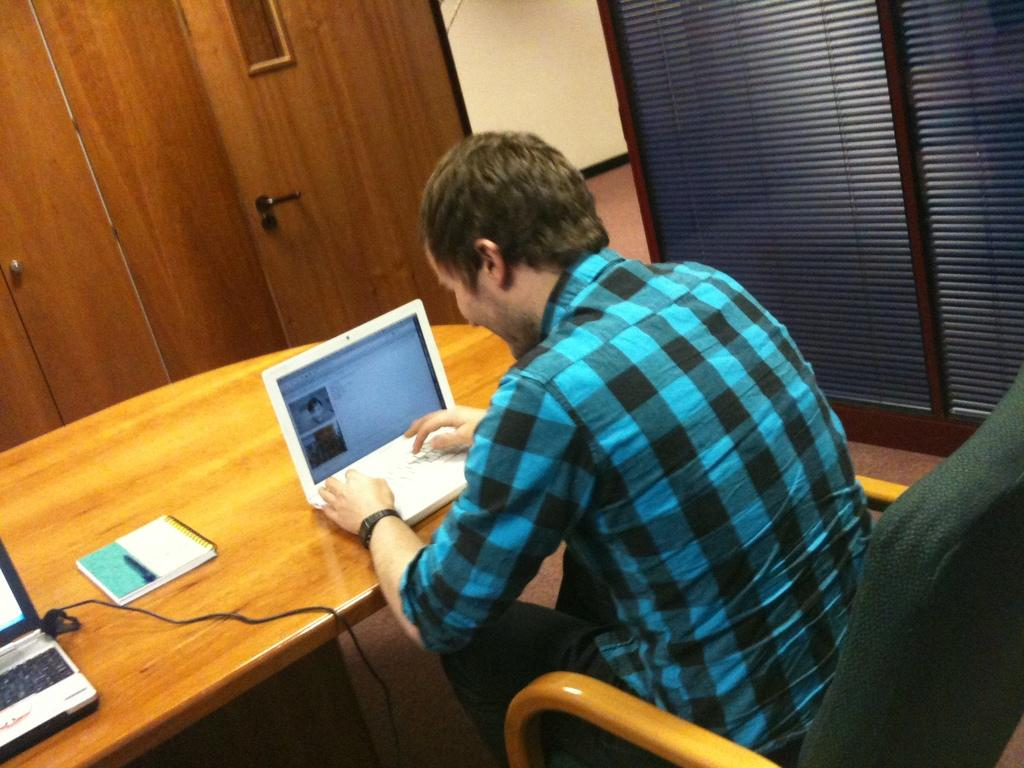What is the main subject of the image? There is a man in the image. What is the man doing in the image? The man is sitting on a chair and looking at a laptop. Where is the man positioned in relation to the table? The man is in front of a table. What can be seen on the right side of the image? There is a wall on the right side of the image. Is there any entrance visible in the image? Yes, there is a door in the image. What type of marble is the man using to play a game in the image? There is no marble or game present in the image; the man is looking at a laptop. What color are the man's teeth in the image? There is no visible indication of the man's teeth in the image. 